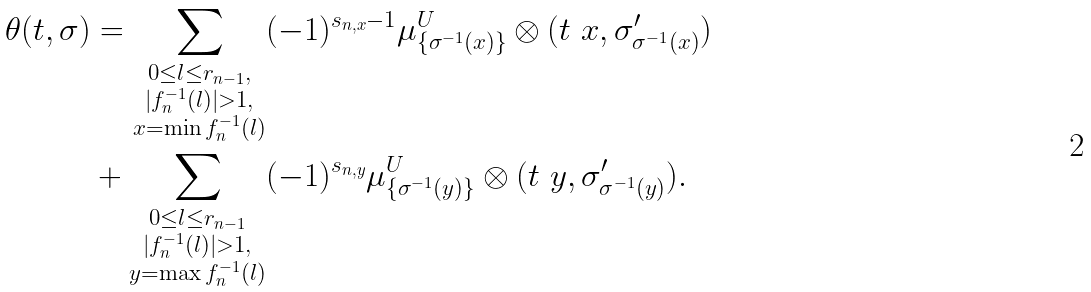Convert formula to latex. <formula><loc_0><loc_0><loc_500><loc_500>\theta ( t , \sigma ) & = \sum _ { \substack { 0 \leq l \leq r _ { n - 1 } , \\ | f _ { n } ^ { - 1 } ( l ) | > 1 , \\ x = \min f _ { n } ^ { - 1 } ( l ) } } ( - 1 ) ^ { s _ { n , x } - 1 } \mu _ { \{ \sigma ^ { - 1 } ( x ) \} } ^ { U } \otimes ( t \ x , \sigma ^ { \prime } _ { \sigma ^ { - 1 } ( x ) } ) \\ & + \sum _ { \substack { 0 \leq l \leq r _ { n - 1 } \\ | f _ { n } ^ { - 1 } ( l ) | > 1 , \\ y = \max f _ { n } ^ { - 1 } ( l ) } } ( - 1 ) ^ { s _ { n , y } } \mu _ { \{ \sigma ^ { - 1 } ( y ) \} } ^ { U } \otimes ( t \ y , \sigma ^ { \prime } _ { \sigma ^ { - 1 } ( y ) } ) .</formula> 